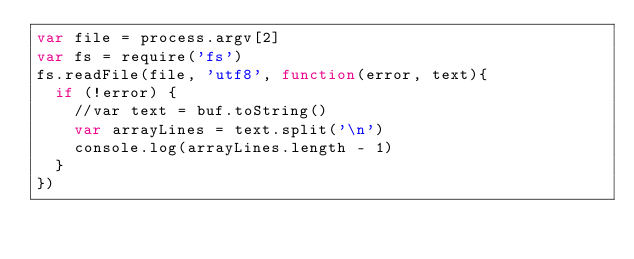Convert code to text. <code><loc_0><loc_0><loc_500><loc_500><_JavaScript_>var file = process.argv[2]
var fs = require('fs')
fs.readFile(file, 'utf8', function(error, text){
  if (!error) {
    //var text = buf.toString()
    var arrayLines = text.split('\n')
    console.log(arrayLines.length - 1)
  }
})
</code> 